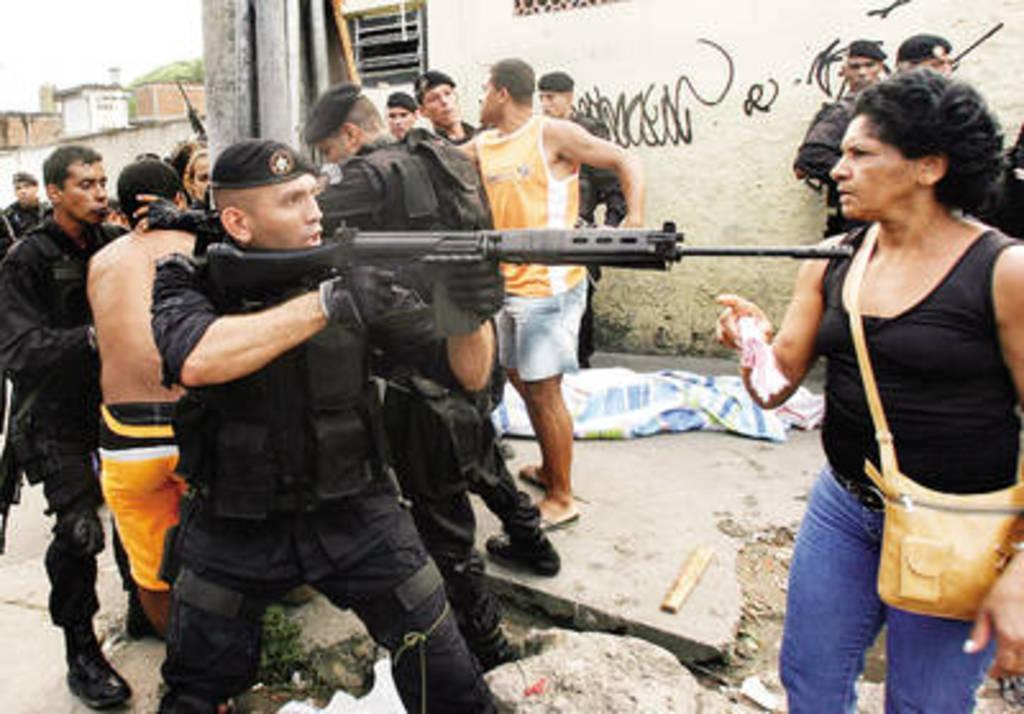How would you summarize this image in a sentence or two? In the foreground of the image there is a person holding gun. In the background of the image there are people standing. There is a building. There is text on the wall. At the bottom of the image there are rocks. 